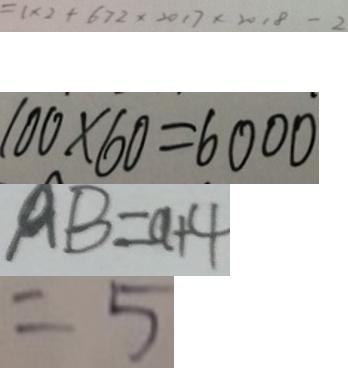<formula> <loc_0><loc_0><loc_500><loc_500>= 1 \times 2 + 6 7 2 \times 2 0 1 7 \times 2 0 1 8 - 2 
 1 0 0 \times 6 0 = 6 0 0 0 
 A B = a + 4 
 = 5</formula> 